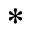Convert formula to latex. <formula><loc_0><loc_0><loc_500><loc_500>^ { * }</formula> 